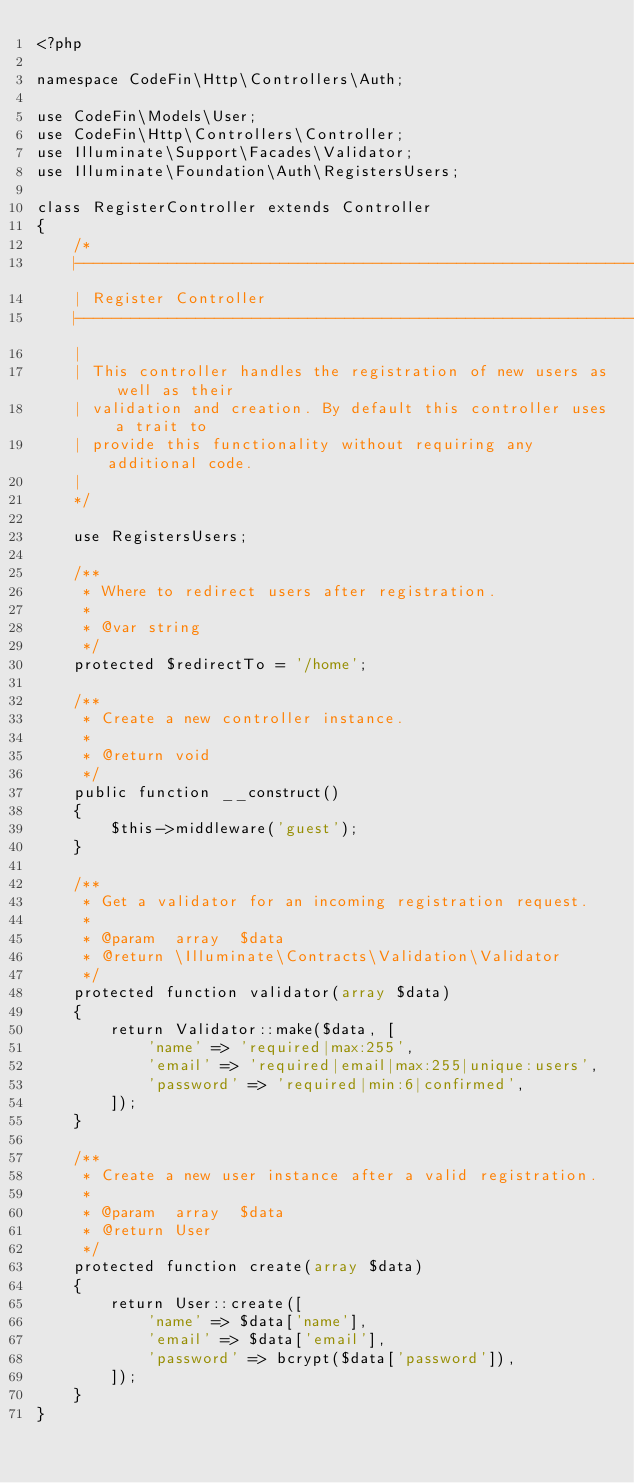Convert code to text. <code><loc_0><loc_0><loc_500><loc_500><_PHP_><?php

namespace CodeFin\Http\Controllers\Auth;

use CodeFin\Models\User;
use CodeFin\Http\Controllers\Controller;
use Illuminate\Support\Facades\Validator;
use Illuminate\Foundation\Auth\RegistersUsers;

class RegisterController extends Controller
{
    /*
    |--------------------------------------------------------------------------
    | Register Controller
    |--------------------------------------------------------------------------
    |
    | This controller handles the registration of new users as well as their
    | validation and creation. By default this controller uses a trait to
    | provide this functionality without requiring any additional code.
    |
    */

    use RegistersUsers;

    /**
     * Where to redirect users after registration.
     *
     * @var string
     */
    protected $redirectTo = '/home';

    /**
     * Create a new controller instance.
     *
     * @return void
     */
    public function __construct()
    {
        $this->middleware('guest');
    }

    /**
     * Get a validator for an incoming registration request.
     *
     * @param  array  $data
     * @return \Illuminate\Contracts\Validation\Validator
     */
    protected function validator(array $data)
    {
        return Validator::make($data, [
            'name' => 'required|max:255',
            'email' => 'required|email|max:255|unique:users',
            'password' => 'required|min:6|confirmed',
        ]);
    }

    /**
     * Create a new user instance after a valid registration.
     *
     * @param  array  $data
     * @return User
     */
    protected function create(array $data)
    {
        return User::create([
            'name' => $data['name'],
            'email' => $data['email'],
            'password' => bcrypt($data['password']),
        ]);
    }
}
</code> 